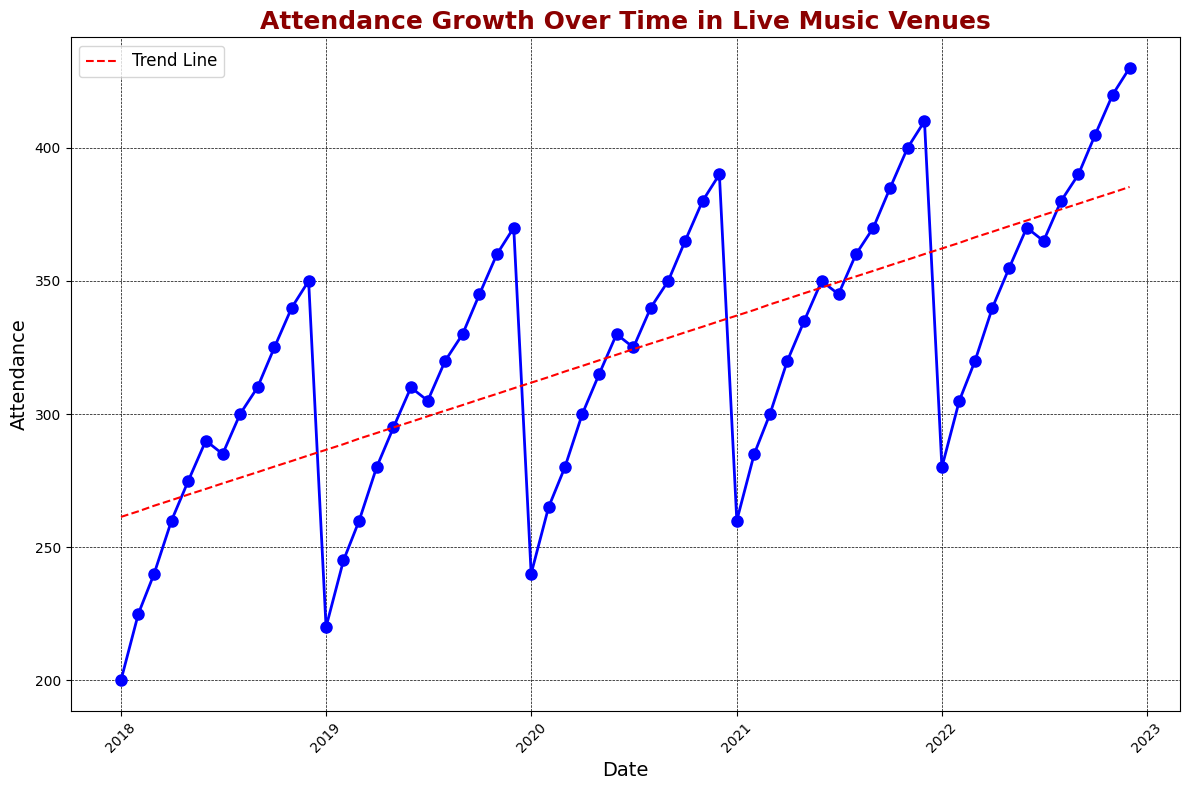What's the overall trend in attendance growth from 2018 to 2022? The trend line (red dashed line) shows a steady increase in attendance over the years. The slope of the trend line is positive, indicating that attendance has consistently grown from 2018 to 2022.
Answer: Steady increase Which year experienced the highest attendance in December? By looking at the data points and the specific values for December, 2022 had the highest attendance with 430.
Answer: 2022 Is there a noticeable dip in attendance during any particular month each year? In the figure, we can observe that there is a slight dip in attendance around July every year, suggesting a seasonal variation.
Answer: July What is the overall increase in attendance from January 2018 to December 2022? The attendance in January 2018 is 200, and in December 2022, it is 430. The overall increase is 430 - 200, which equals 230.
Answer: 230 How does the attendance in July 2020 compare to July 2021? From the figure, July 2020 attendance is around 325 and July 2021 attendance is around 345, indicating that July 2021 had higher attendance than July 2020.
Answer: July 2021 is higher What is the average attendance growth per year from 2018 to 2022? Total increase from January 2018 to December 2022 is 230. This spans 5 years, so the average yearly growth is 230 / 5 = 46.
Answer: 46 Which month has the highest average attendance across all the years? December consistently shows the highest attendance in each year. Summing up December attendances (350 + 370 + 390 + 410 + 430) and dividing by 5 gives an average of (350 + 370 + 390 + 410 + 430) / 5 = 390.
Answer: December Has the attendance growth rate increased, decreased, or remained consistent over the years? The trend line (red dashed line) shows a consistent linear growth over the years, implying that the growth rate has remained consistent.
Answer: Remained consistent What are the attendance values in June 2019 and June 2022, and how do they compare? Attendance in June 2019 is 310 and in June 2022 is 370. Subtracting these values, 370 - 310, the increase is 60.
Answer: June 2022 is higher by 60 Is there any seasonality pattern observable in the visual data? Yes, attendance tends to dip slightly around mid-year (July) and peak at the end (December), indicating a seasonality pattern.
Answer: Yes 